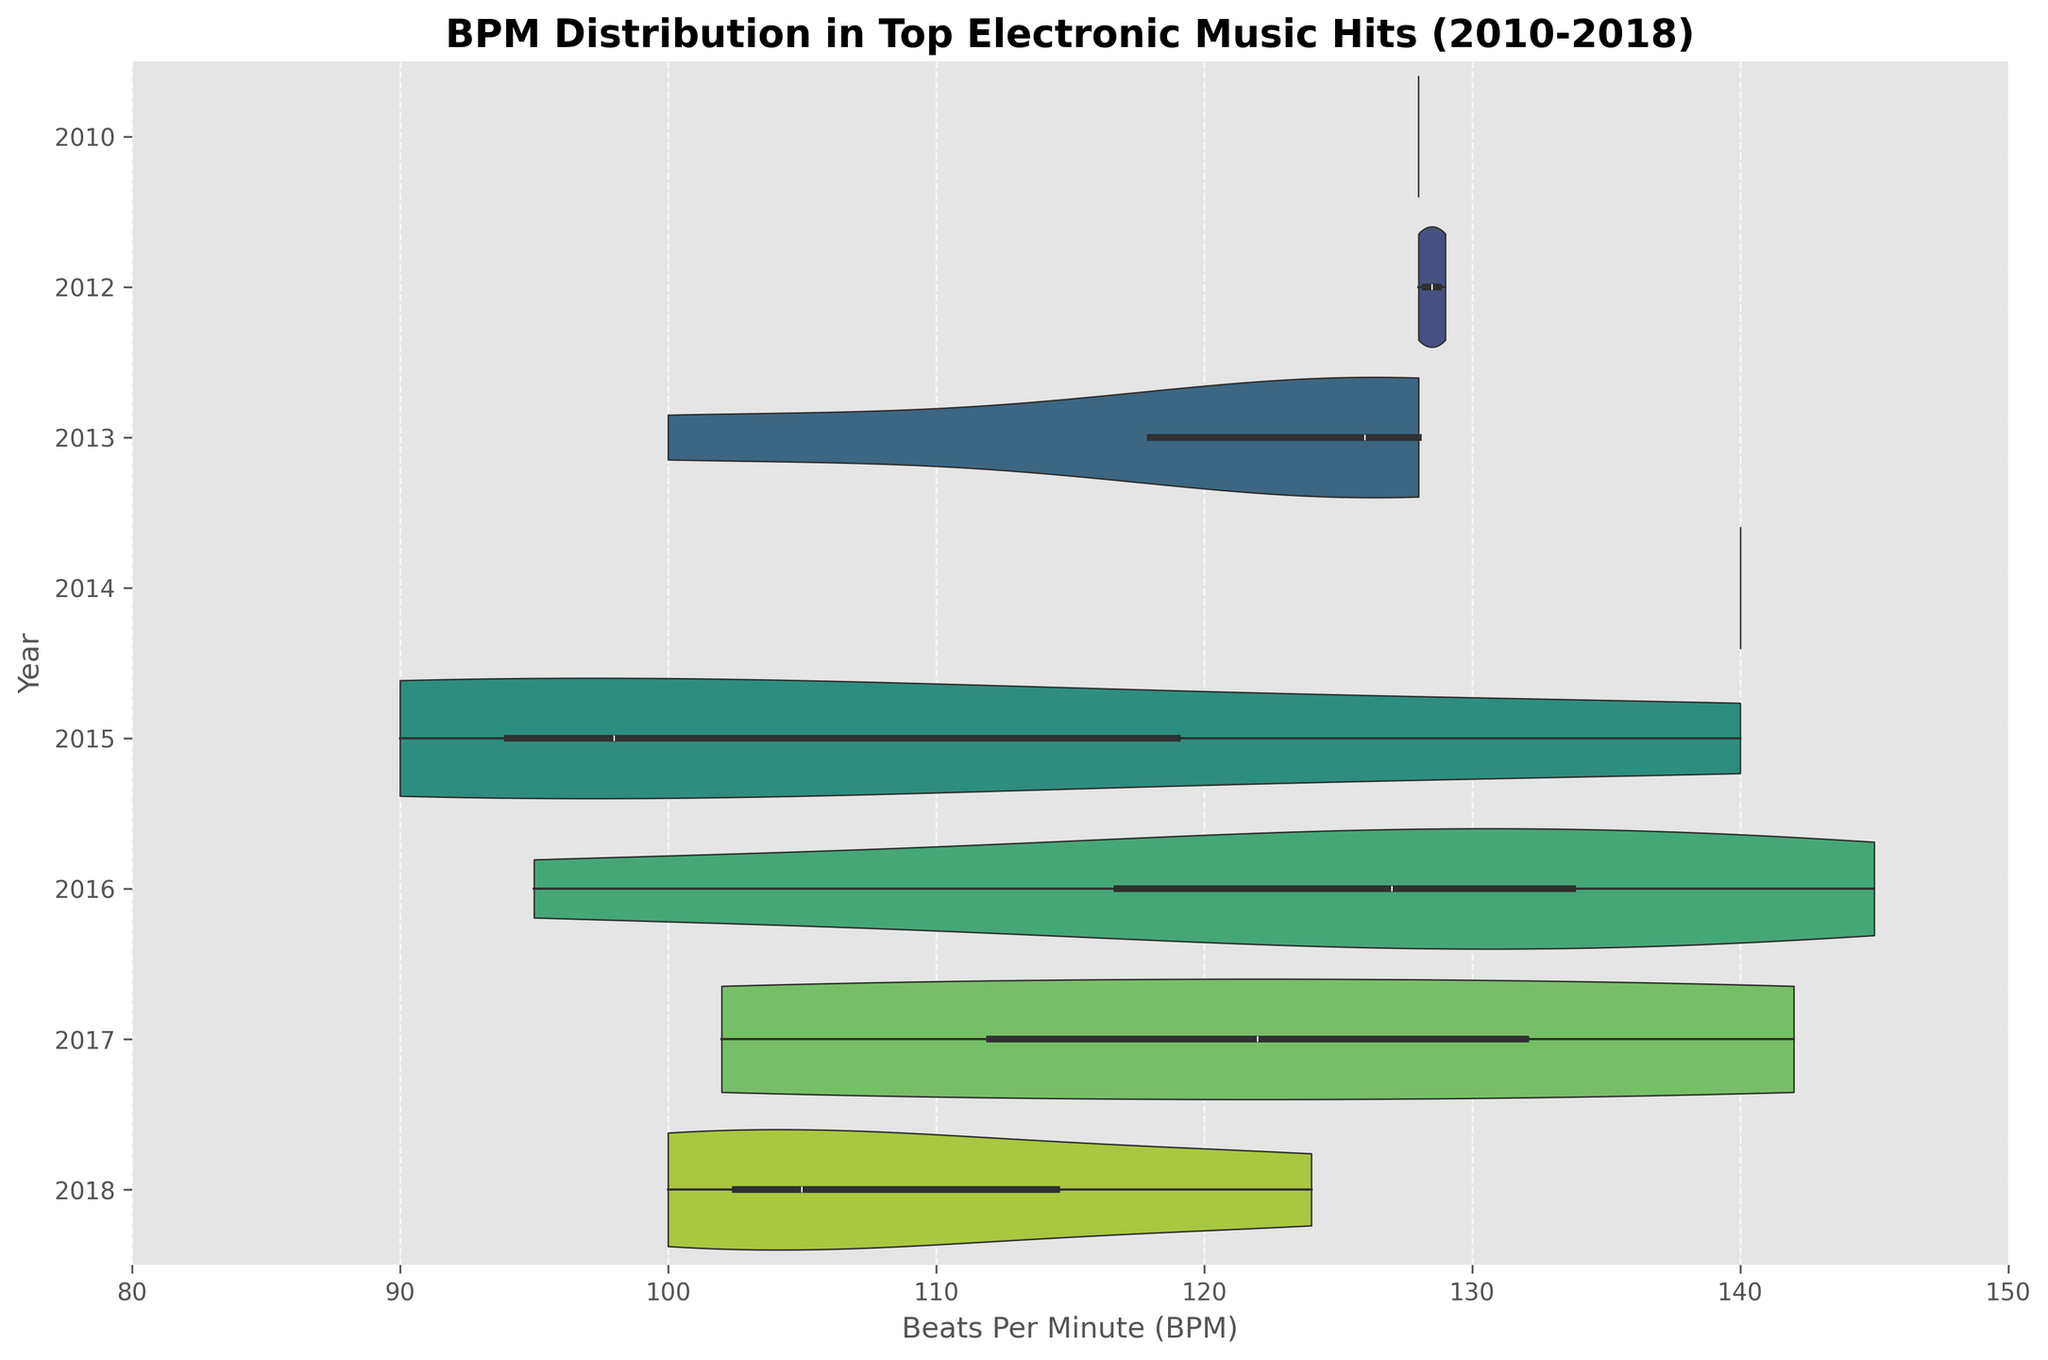What is the range of BPM values in the dataset? The smallest BPM value is 90 (Alan Walker's "Faded"), and the highest BPM value is 145 (Marshmello's "Alone"). So the range is 145 - 90.
Answer: 55 What year has the widest distribution of BPM values? Observing the width of the violins for each year, the year with the widest distribution is 2016.
Answer: 2016 Are there any years where the median BPM consistently falls within the same narrow BPM range? The figure shows that the median BPM in the years 2010, 2012, 2013, and 2014 is around 128-130 BPM.
Answer: Yes Which year has the lowest median BPM value? The year 2015 has the lowest median BPM, as indicated by the position of the central box in the violin plot for that year.
Answer: 2015 Comparing 2013 and 2014, which year exhibits a broader range of BPM values? The year 2014 shows a broader range of BPM values, as indicated by the length of the violin plot along the horizontal axis.
Answer: 2014 How do the median BPM values for 2010 and 2018 compare? The median BPM for 2010 is roughly 128, while for 2018, it is also around 124. Both fall within a similar range but with a slight difference in their median values.
Answer: Similar with slight difference Which year shows the least variability in BPM values? The year 2010 shows the least variability, as indicated by the compactness of the violin plot for that year.
Answer: 2010 What is the most common BPM range across these top electronic music hits from 2010-2018? Most of the music tracks tend to fall within the BPM range of roughly 120 to 130 BPM as seen from the density of the violin plots in this range.
Answer: 120-130 BPM Is there a year where BPM values above 140 are common? Yes, the year 2014 and 2016 show a violin plot that includes BPM values above 140, indicating that some tracks fall within this range.
Answer: 2014 and 2016 